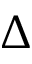Convert formula to latex. <formula><loc_0><loc_0><loc_500><loc_500>\Delta</formula> 